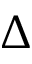Convert formula to latex. <formula><loc_0><loc_0><loc_500><loc_500>\Delta</formula> 